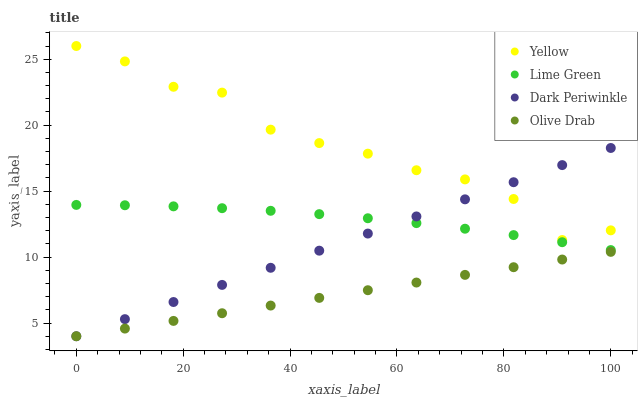Does Olive Drab have the minimum area under the curve?
Answer yes or no. Yes. Does Yellow have the maximum area under the curve?
Answer yes or no. Yes. Does Lime Green have the minimum area under the curve?
Answer yes or no. No. Does Lime Green have the maximum area under the curve?
Answer yes or no. No. Is Olive Drab the smoothest?
Answer yes or no. Yes. Is Yellow the roughest?
Answer yes or no. Yes. Is Lime Green the smoothest?
Answer yes or no. No. Is Lime Green the roughest?
Answer yes or no. No. Does Olive Drab have the lowest value?
Answer yes or no. Yes. Does Lime Green have the lowest value?
Answer yes or no. No. Does Yellow have the highest value?
Answer yes or no. Yes. Does Lime Green have the highest value?
Answer yes or no. No. Is Olive Drab less than Lime Green?
Answer yes or no. Yes. Is Lime Green greater than Olive Drab?
Answer yes or no. Yes. Does Dark Periwinkle intersect Lime Green?
Answer yes or no. Yes. Is Dark Periwinkle less than Lime Green?
Answer yes or no. No. Is Dark Periwinkle greater than Lime Green?
Answer yes or no. No. Does Olive Drab intersect Lime Green?
Answer yes or no. No. 